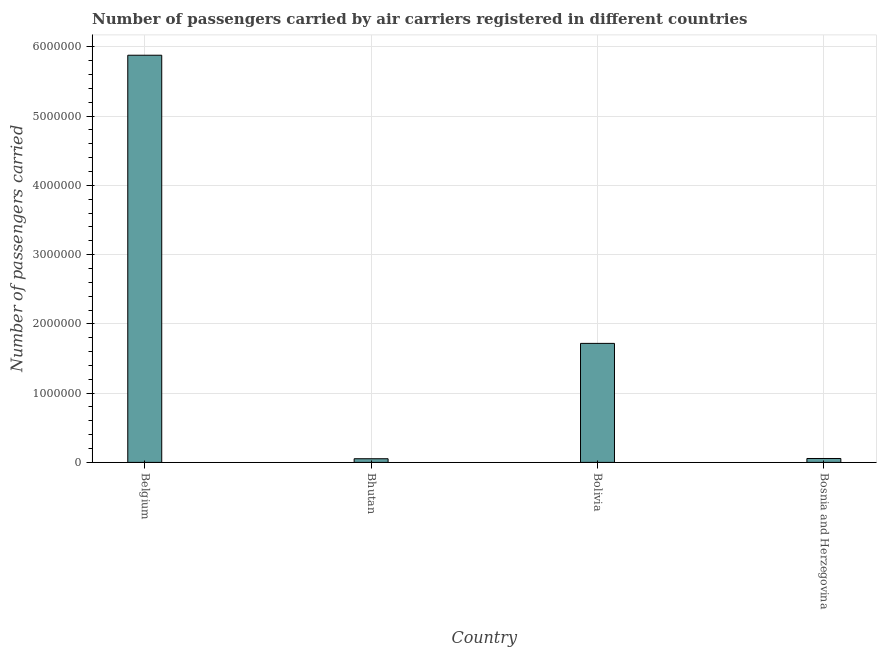What is the title of the graph?
Keep it short and to the point. Number of passengers carried by air carriers registered in different countries. What is the label or title of the X-axis?
Offer a very short reply. Country. What is the label or title of the Y-axis?
Ensure brevity in your answer.  Number of passengers carried. What is the number of passengers carried in Bolivia?
Keep it short and to the point. 1.72e+06. Across all countries, what is the maximum number of passengers carried?
Provide a short and direct response. 5.88e+06. Across all countries, what is the minimum number of passengers carried?
Offer a terse response. 5.28e+04. In which country was the number of passengers carried maximum?
Offer a very short reply. Belgium. In which country was the number of passengers carried minimum?
Keep it short and to the point. Bhutan. What is the sum of the number of passengers carried?
Offer a terse response. 7.71e+06. What is the difference between the number of passengers carried in Belgium and Bhutan?
Make the answer very short. 5.83e+06. What is the average number of passengers carried per country?
Offer a terse response. 1.93e+06. What is the median number of passengers carried?
Ensure brevity in your answer.  8.87e+05. In how many countries, is the number of passengers carried greater than 5800000 ?
Ensure brevity in your answer.  1. What is the ratio of the number of passengers carried in Bhutan to that in Bosnia and Herzegovina?
Offer a very short reply. 0.94. Is the difference between the number of passengers carried in Bolivia and Bosnia and Herzegovina greater than the difference between any two countries?
Give a very brief answer. No. What is the difference between the highest and the second highest number of passengers carried?
Your response must be concise. 4.16e+06. What is the difference between the highest and the lowest number of passengers carried?
Provide a succinct answer. 5.83e+06. In how many countries, is the number of passengers carried greater than the average number of passengers carried taken over all countries?
Your answer should be very brief. 1. What is the difference between two consecutive major ticks on the Y-axis?
Your answer should be very brief. 1.00e+06. Are the values on the major ticks of Y-axis written in scientific E-notation?
Give a very brief answer. No. What is the Number of passengers carried in Belgium?
Keep it short and to the point. 5.88e+06. What is the Number of passengers carried of Bhutan?
Your answer should be compact. 5.28e+04. What is the Number of passengers carried in Bolivia?
Make the answer very short. 1.72e+06. What is the Number of passengers carried of Bosnia and Herzegovina?
Provide a short and direct response. 5.63e+04. What is the difference between the Number of passengers carried in Belgium and Bhutan?
Your answer should be very brief. 5.83e+06. What is the difference between the Number of passengers carried in Belgium and Bolivia?
Offer a very short reply. 4.16e+06. What is the difference between the Number of passengers carried in Belgium and Bosnia and Herzegovina?
Keep it short and to the point. 5.82e+06. What is the difference between the Number of passengers carried in Bhutan and Bolivia?
Your response must be concise. -1.67e+06. What is the difference between the Number of passengers carried in Bhutan and Bosnia and Herzegovina?
Provide a short and direct response. -3508. What is the difference between the Number of passengers carried in Bolivia and Bosnia and Herzegovina?
Your answer should be compact. 1.66e+06. What is the ratio of the Number of passengers carried in Belgium to that in Bhutan?
Your response must be concise. 111.33. What is the ratio of the Number of passengers carried in Belgium to that in Bolivia?
Ensure brevity in your answer.  3.42. What is the ratio of the Number of passengers carried in Belgium to that in Bosnia and Herzegovina?
Give a very brief answer. 104.39. What is the ratio of the Number of passengers carried in Bhutan to that in Bolivia?
Provide a succinct answer. 0.03. What is the ratio of the Number of passengers carried in Bhutan to that in Bosnia and Herzegovina?
Keep it short and to the point. 0.94. What is the ratio of the Number of passengers carried in Bolivia to that in Bosnia and Herzegovina?
Keep it short and to the point. 30.51. 